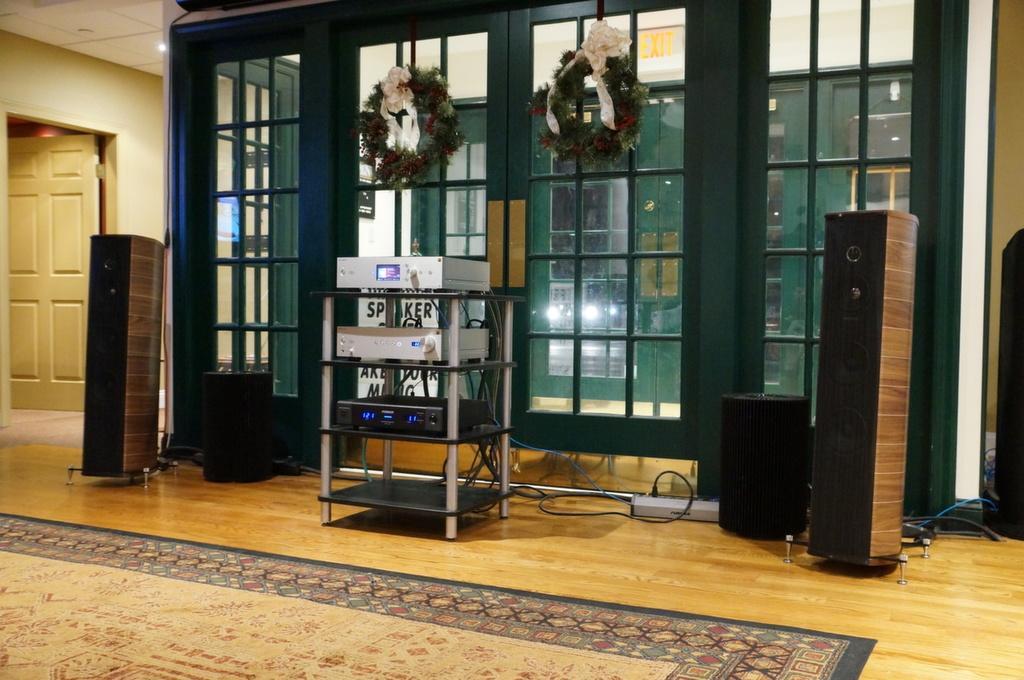Describe this image in one or two sentences. In this picture we can see speakers on the floor, here we can see a floor mat, some devices, door, lights and some objects and in the background we can see a wall, roof. 